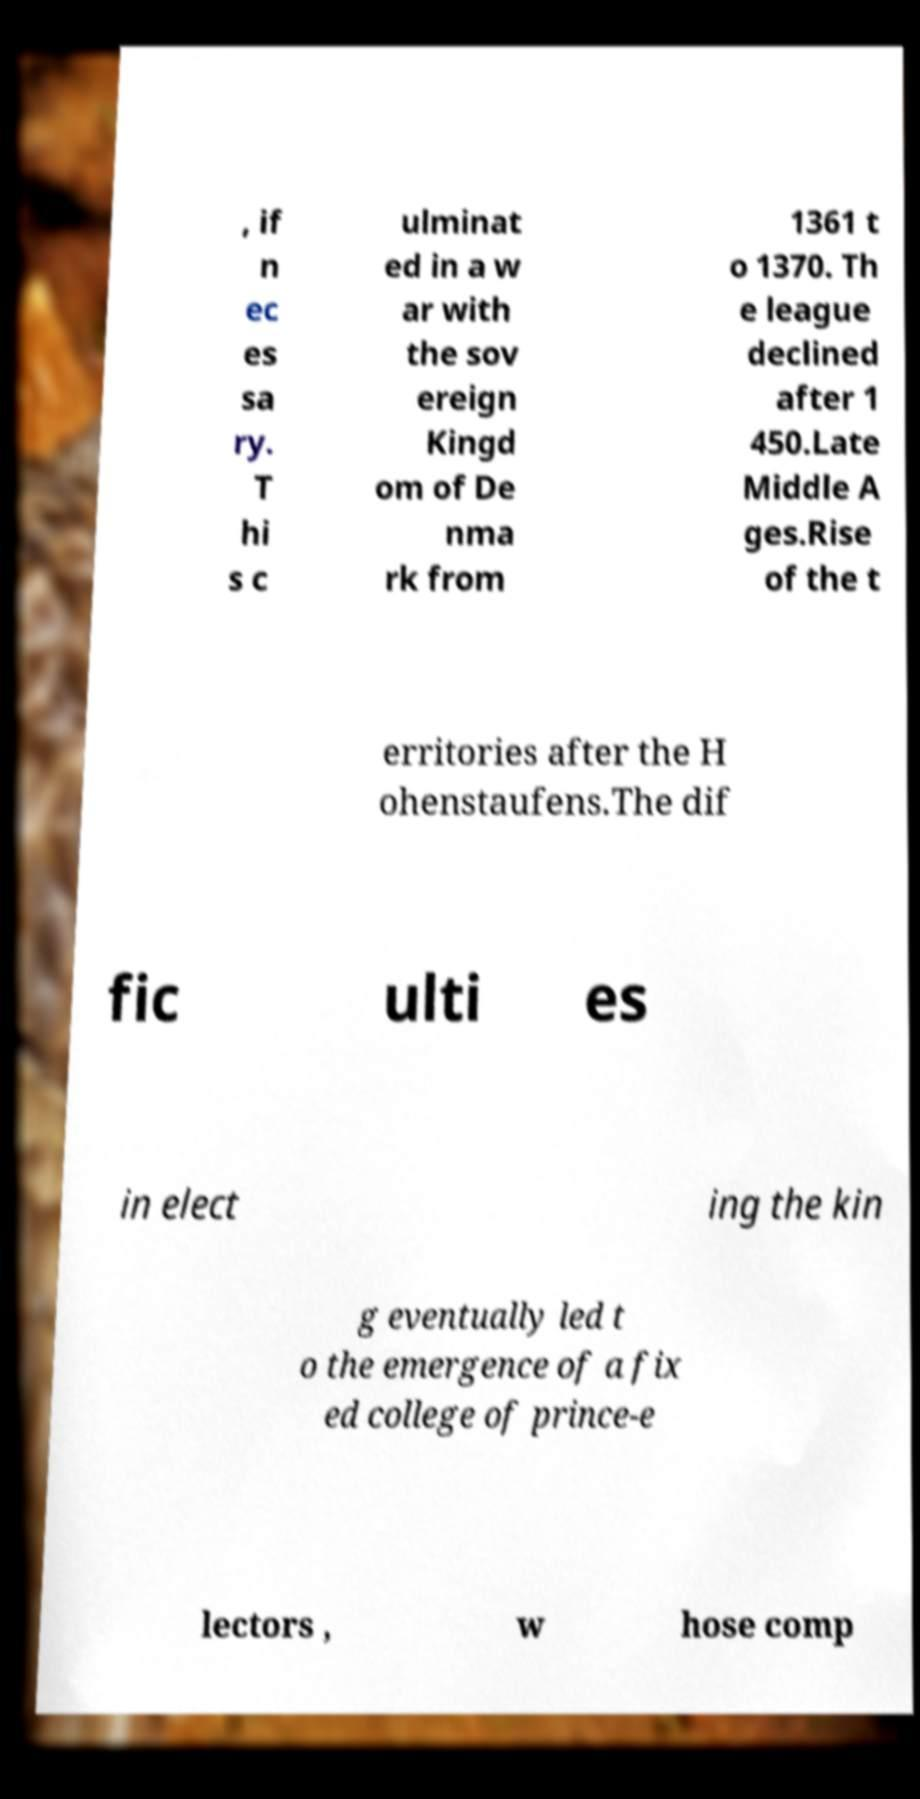Please identify and transcribe the text found in this image. , if n ec es sa ry. T hi s c ulminat ed in a w ar with the sov ereign Kingd om of De nma rk from 1361 t o 1370. Th e league declined after 1 450.Late Middle A ges.Rise of the t erritories after the H ohenstaufens.The dif fic ulti es in elect ing the kin g eventually led t o the emergence of a fix ed college of prince-e lectors , w hose comp 